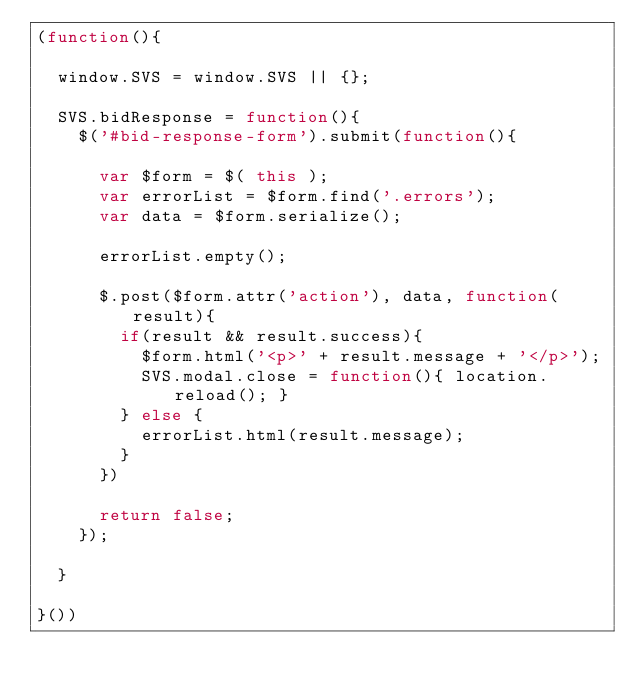Convert code to text. <code><loc_0><loc_0><loc_500><loc_500><_JavaScript_>(function(){

	window.SVS = window.SVS || {};

	SVS.bidResponse = function(){
		$('#bid-response-form').submit(function(){

			var $form = $( this );
			var errorList = $form.find('.errors');
			var data = $form.serialize();
			
			errorList.empty();

			$.post($form.attr('action'), data, function(result){
				if(result && result.success){
					$form.html('<p>' + result.message + '</p>');
					SVS.modal.close = function(){ location.reload(); }
				} else {
					errorList.html(result.message);
				}
			})	

			return false;		
		});

	}

}())
	</code> 